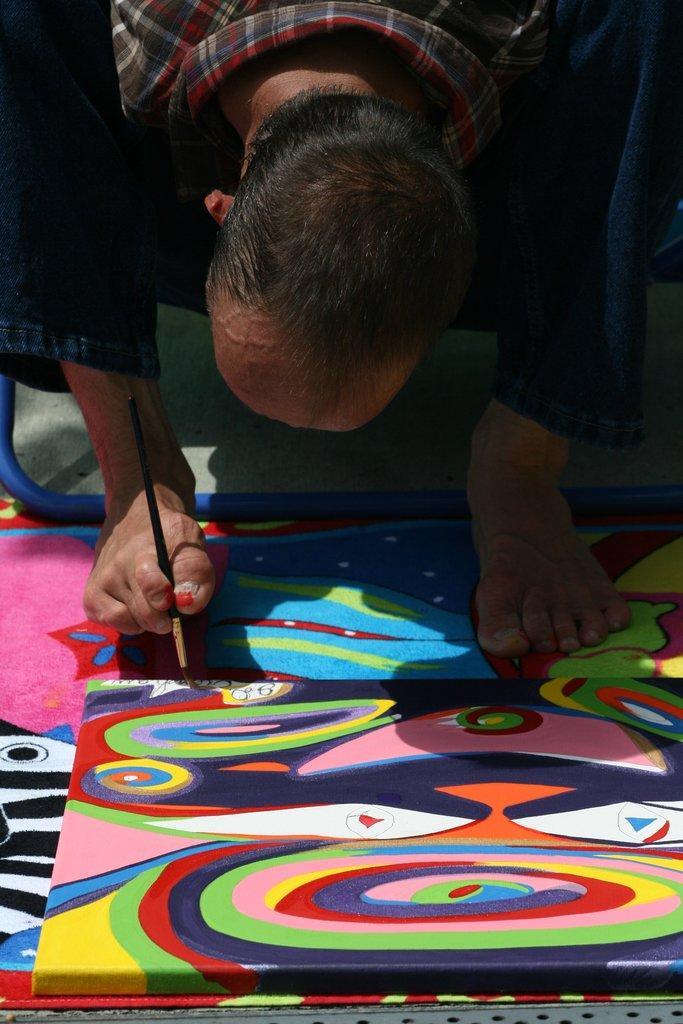Can you describe this image briefly? In this image there is a person holding the brush with his leg and he is painting on the board. 